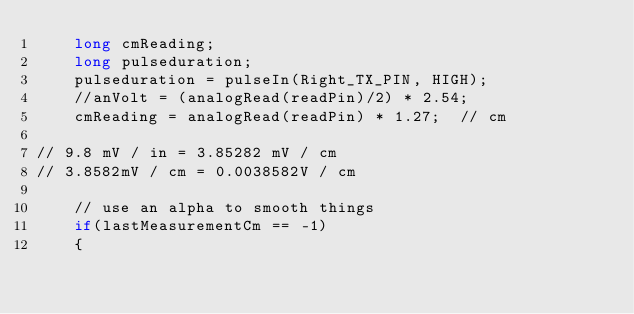<code> <loc_0><loc_0><loc_500><loc_500><_C++_>    long cmReading;
    long pulseduration;
    pulseduration = pulseIn(Right_TX_PIN, HIGH);
    //anVolt = (analogRead(readPin)/2) * 2.54;
    cmReading = analogRead(readPin) * 1.27;  // cm
   
// 9.8 mV / in = 3.85282 mV / cm
// 3.8582mV / cm = 0.0038582V / cm

    // use an alpha to smooth things
    if(lastMeasurementCm == -1)
    {</code> 